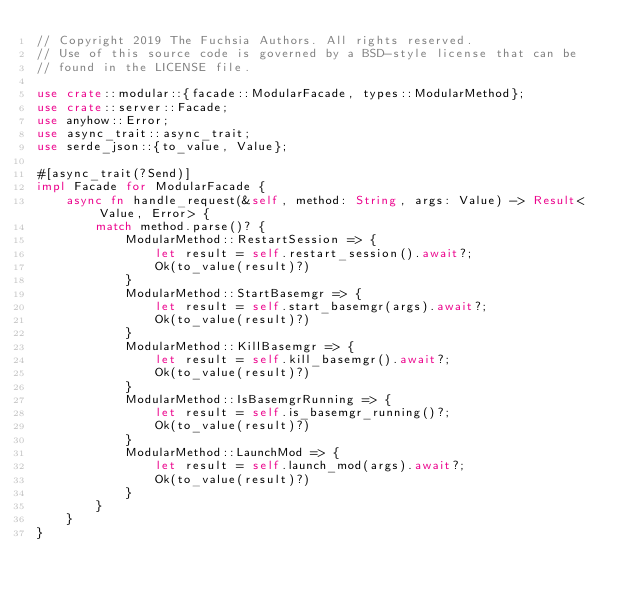<code> <loc_0><loc_0><loc_500><loc_500><_Rust_>// Copyright 2019 The Fuchsia Authors. All rights reserved.
// Use of this source code is governed by a BSD-style license that can be
// found in the LICENSE file.

use crate::modular::{facade::ModularFacade, types::ModularMethod};
use crate::server::Facade;
use anyhow::Error;
use async_trait::async_trait;
use serde_json::{to_value, Value};

#[async_trait(?Send)]
impl Facade for ModularFacade {
    async fn handle_request(&self, method: String, args: Value) -> Result<Value, Error> {
        match method.parse()? {
            ModularMethod::RestartSession => {
                let result = self.restart_session().await?;
                Ok(to_value(result)?)
            }
            ModularMethod::StartBasemgr => {
                let result = self.start_basemgr(args).await?;
                Ok(to_value(result)?)
            }
            ModularMethod::KillBasemgr => {
                let result = self.kill_basemgr().await?;
                Ok(to_value(result)?)
            }
            ModularMethod::IsBasemgrRunning => {
                let result = self.is_basemgr_running()?;
                Ok(to_value(result)?)
            }
            ModularMethod::LaunchMod => {
                let result = self.launch_mod(args).await?;
                Ok(to_value(result)?)
            }
        }
    }
}
</code> 